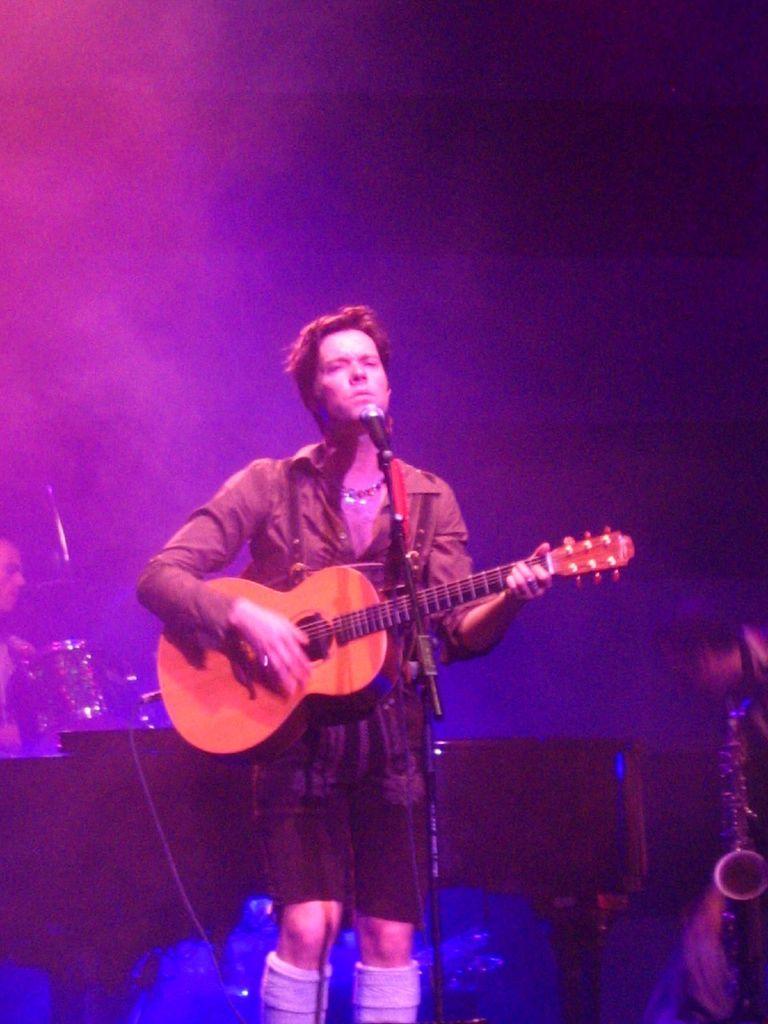Please provide a concise description of this image. In this image i can see a man wearing a shirt and a short standing and holding a guitar. I can see a microphone in front of him. In the background i can see few other people holding musical instruments in their hands. 